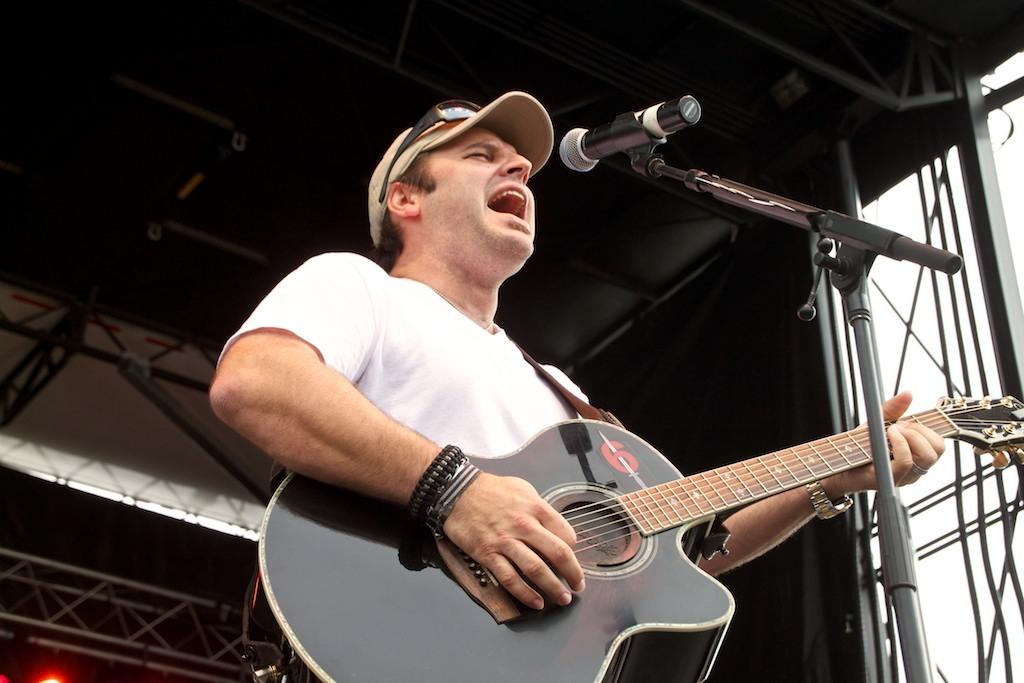Who is the main subject in the image? There is a man in the image. What is the man wearing? The man is wearing a white t-shirt and a cap. What is the man holding in the image? The man is holding a guitar. What might be the setting of the image? The setting may be a stage performance. What type of secretary can be seen working in the image? There is no secretary present in the image; it features a man holding a guitar. What shape is the square that the man is standing on in the image? There is no square mentioned or visible in the image; it only shows a man holding a guitar. 